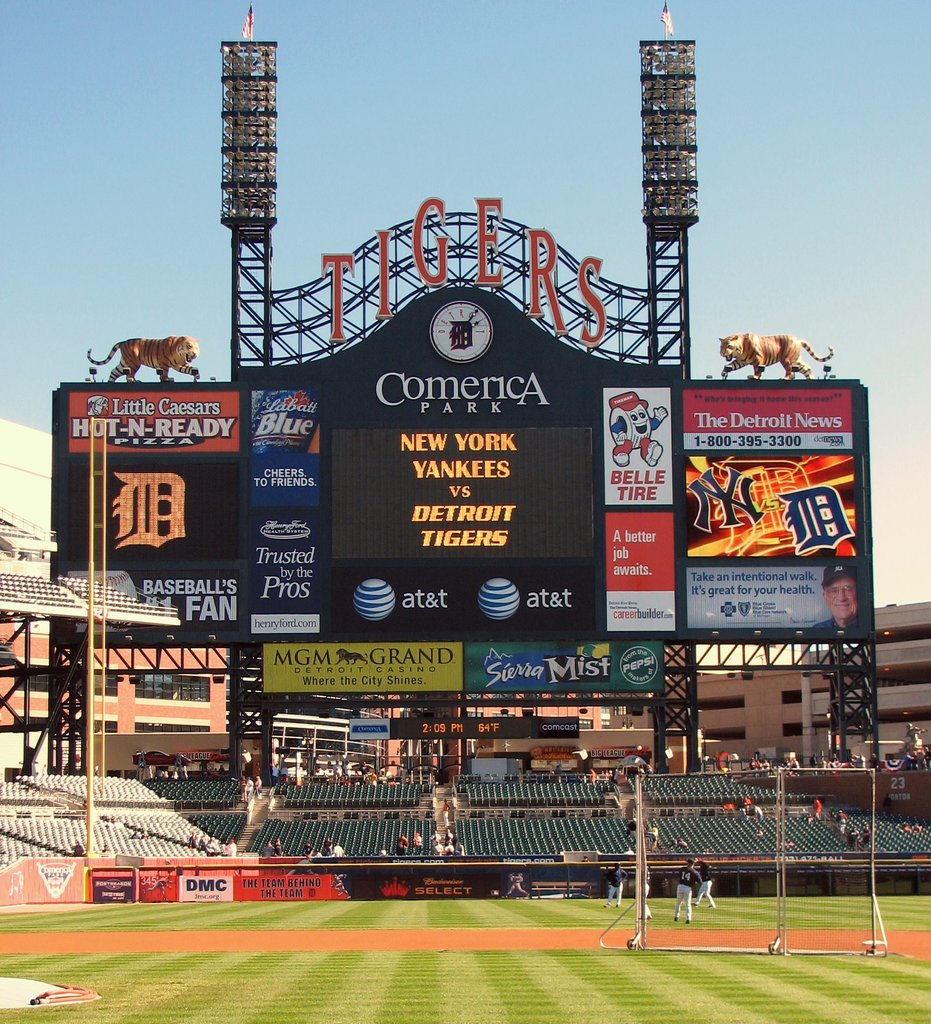Provide a one-sentence caption for the provided image.
Reference OCR token: Little, Caesars, ComericA, HO, -READY, Blue, TheDetroit, TheDetroitN, News, NEW, YORK, 395-3300, YANKEES, JE, TOCHEENSS, ETROIT, Morh, Trusted, TIGERS, SB, JIB, awaits., BASEBALL'S, Pros, Pros, FAN, henryford.com, at&t, at&t, MGM, GRAND, Sterra, Mist, ZZAZI, TEAMBEHIN The teams playing baseball are the Yankees and Tigers. 